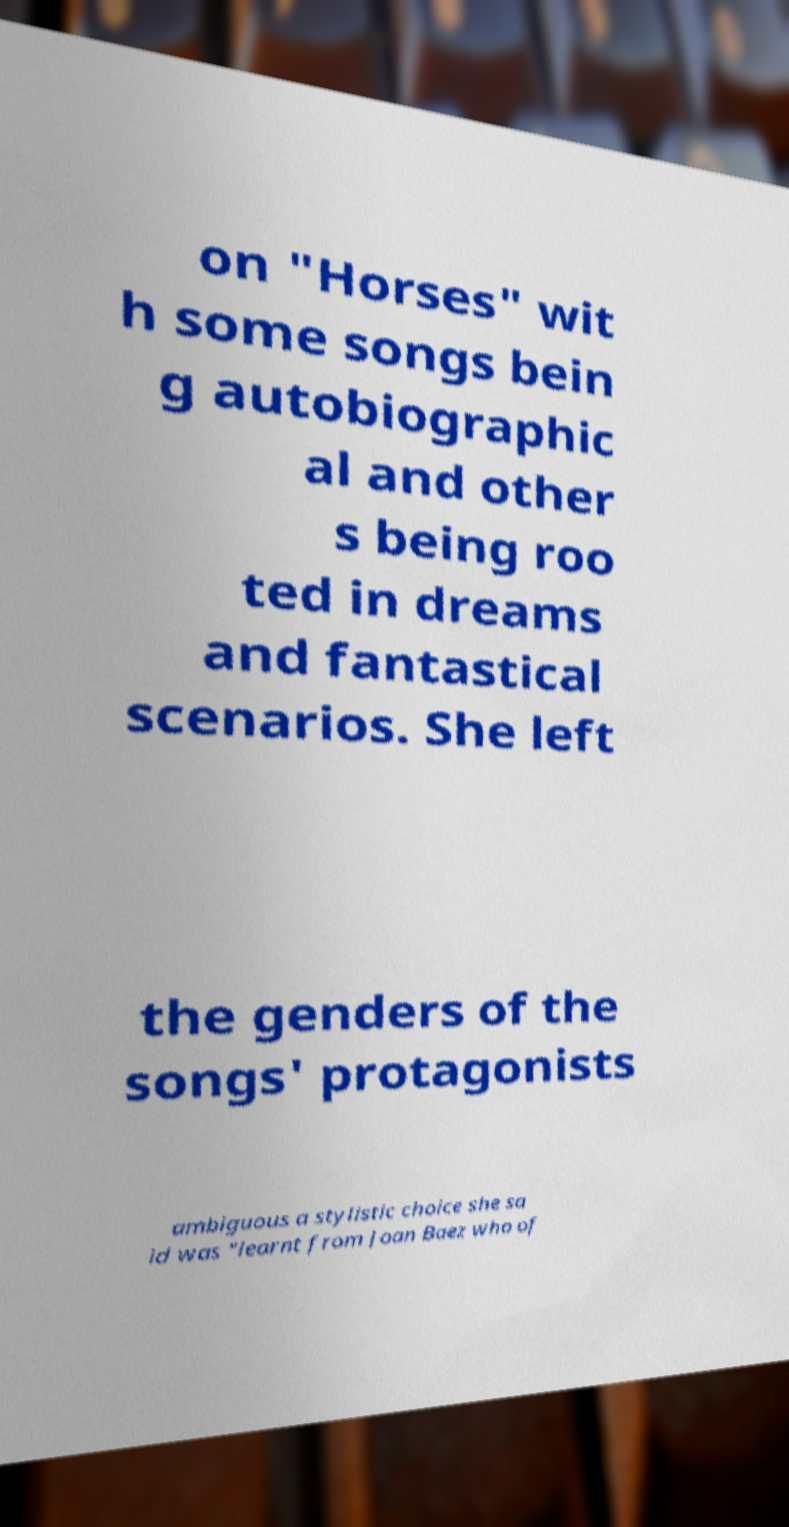Could you assist in decoding the text presented in this image and type it out clearly? on "Horses" wit h some songs bein g autobiographic al and other s being roo ted in dreams and fantastical scenarios. She left the genders of the songs' protagonists ambiguous a stylistic choice she sa id was "learnt from Joan Baez who of 